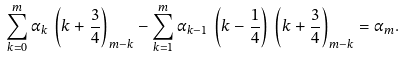<formula> <loc_0><loc_0><loc_500><loc_500>\sum ^ { m } _ { k = 0 } \alpha _ { k } \, \left ( k + \frac { 3 } { 4 } \right ) _ { m - k } - \sum ^ { m } _ { k = 1 } \alpha _ { k - 1 } \, \left ( k - \frac { 1 } { 4 } \right ) \, \left ( k + \frac { 3 } { 4 } \right ) _ { m - k } = \alpha _ { m } .</formula> 